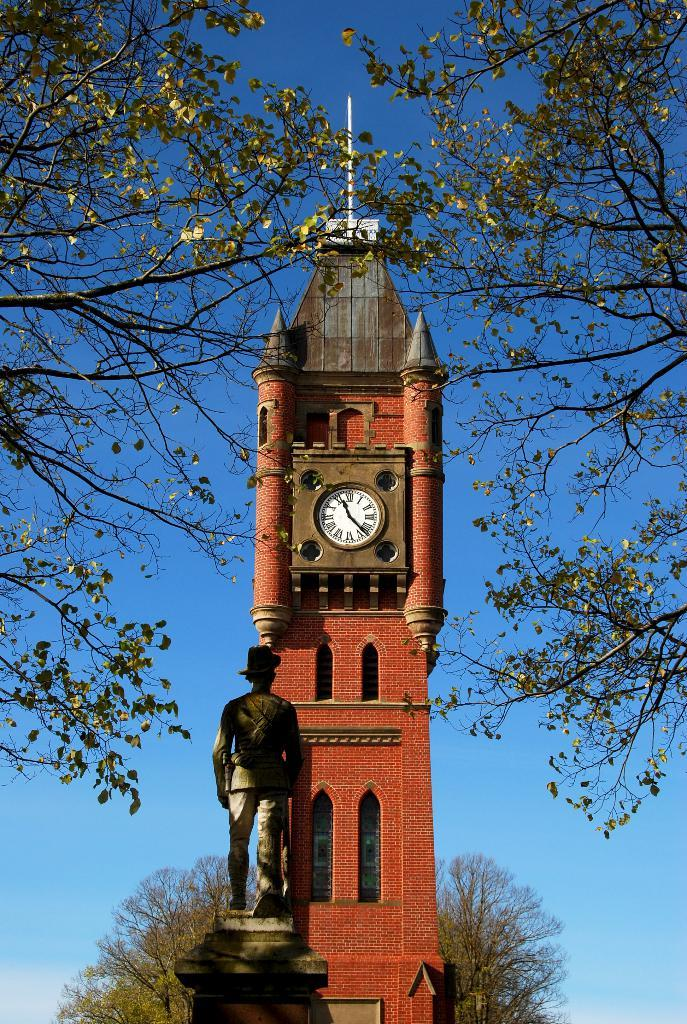<image>
Provide a brief description of the given image. A tower with a clock on it and the time reads 11:22 